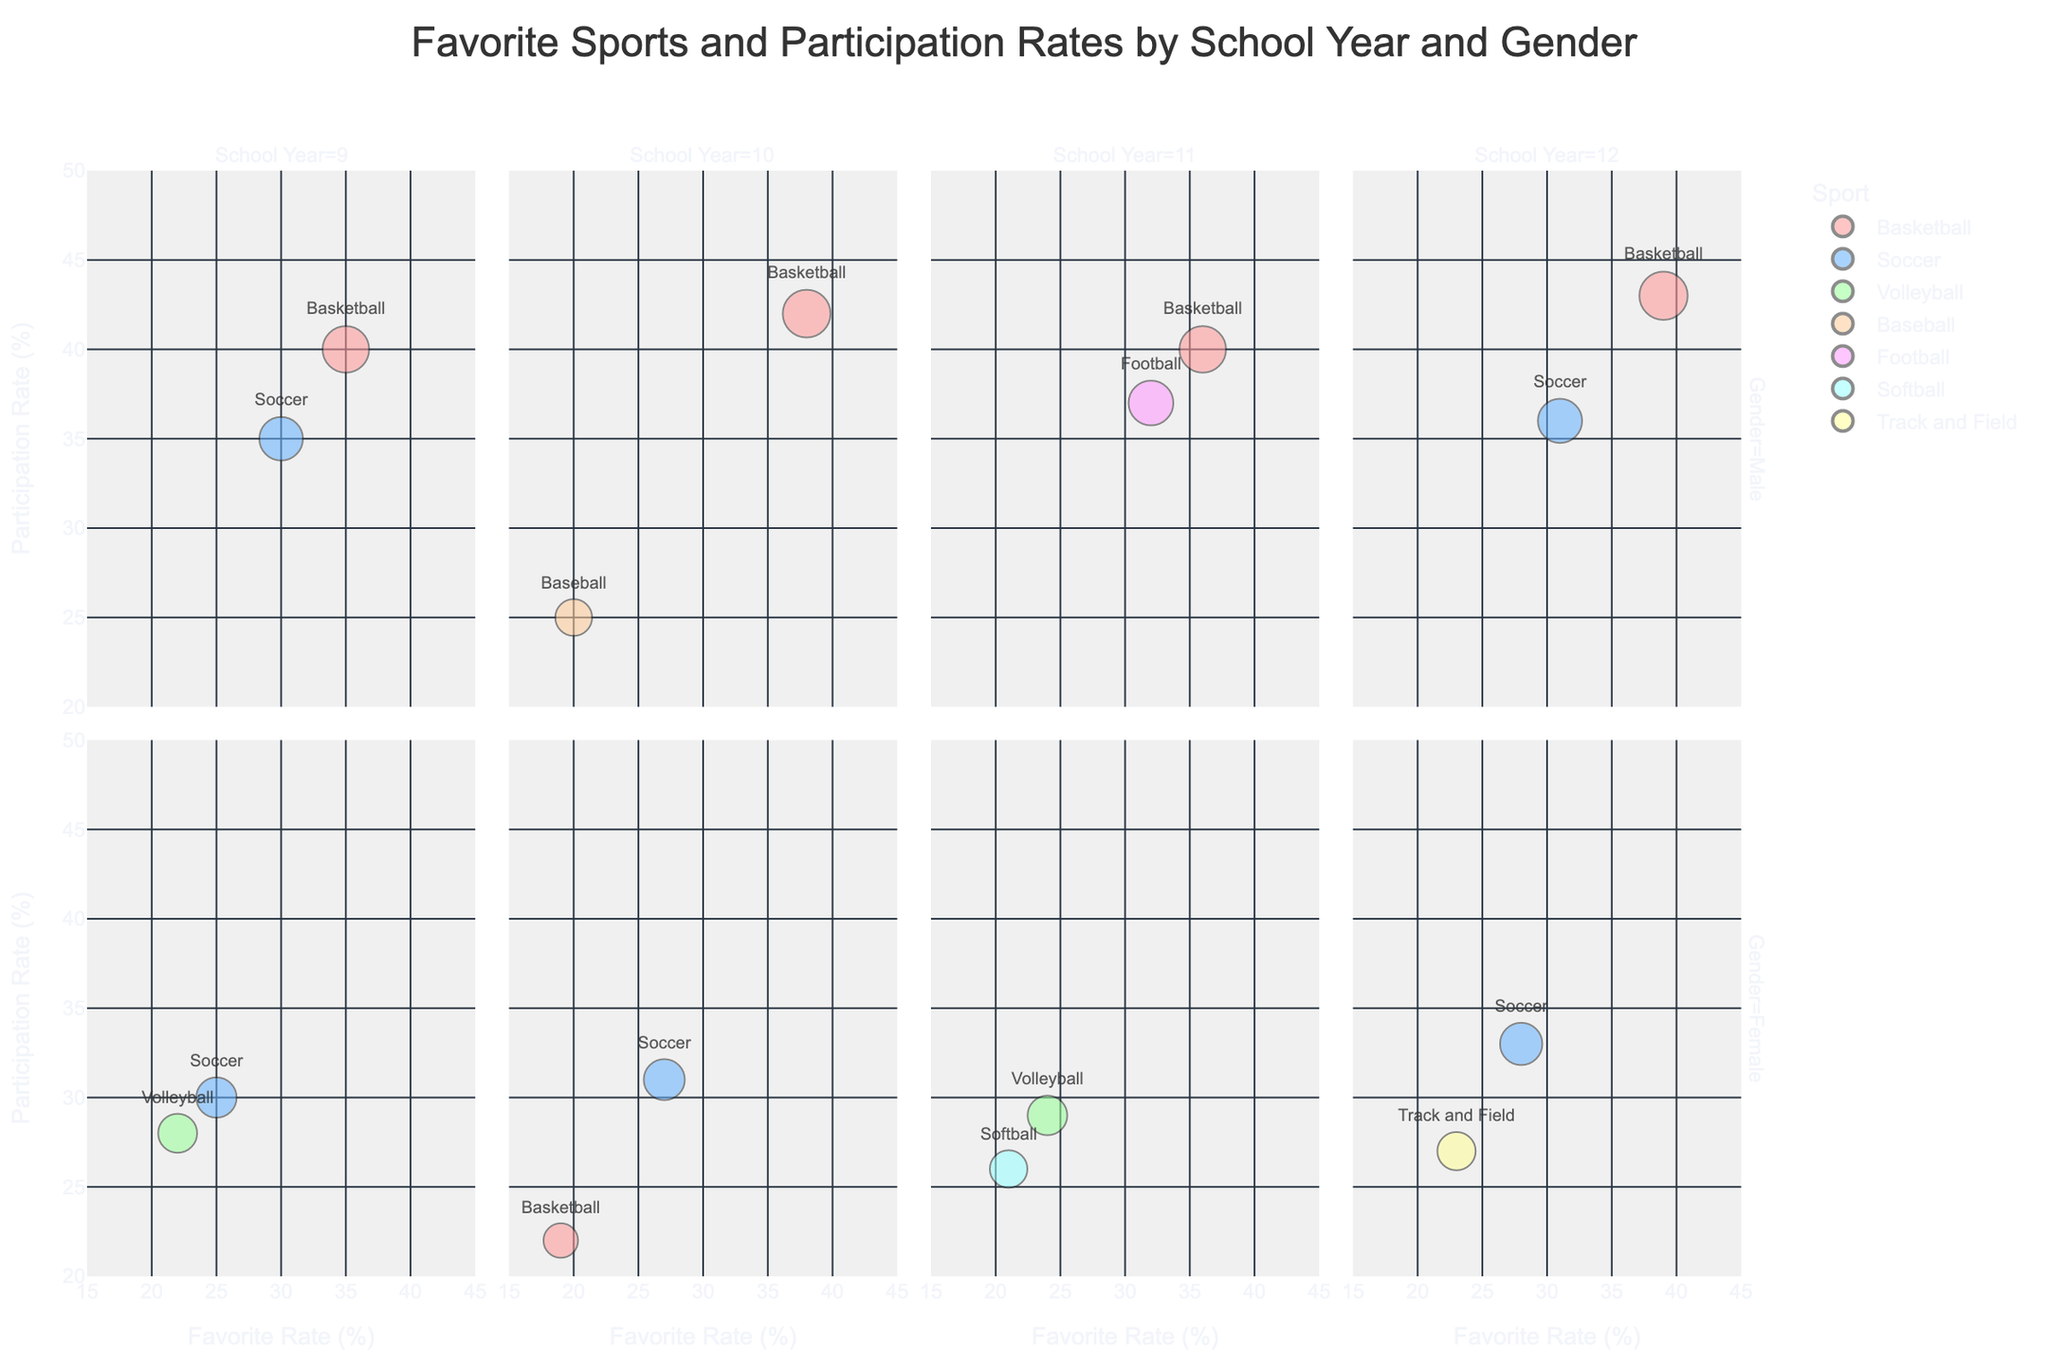Which sport has the highest favorite rate among 9th-grade males? The figure shows a bubble for each sport, categorized by school year and gender. Look at the bubbles in the 9th-grade male pane. Basketball has the highest favorite rate.
Answer: Basketball Which sport has the lowest participation rate among 10th-grade females? Look at the bubbles in the 10th-grade female pane and compare their 'Participation Rate (%)'. Basketball has the lowest participation rate.
Answer: Basketball What is the participation rate for Soccer among 12th-grade females? Identify the bubble for Soccer in the 12th-grade female pane and check the 'Participation Rate (%)'. Soccer has a participation rate of 33%.
Answer: 33% Is the favorite rate of Football higher than that of Baseball for 11th-grade males? Check the 11th-grade male pane and compare the favorite rates for Football and Baseball. Football has a favorite rate of 32%, and Baseball doesn't appear for 11th-grade males.
Answer: Yes Which sport is the most popular (highest favorite rate) among females in each school year? Examine the bubbles representing female students across each school year and identify the highest favorite rates in each pane. Soccer in 9th grade, Soccer in 10th grade, Volleyball in 11th grade, and Soccer in 12th grade are the sports with the highest favorite rates.
Answer: Soccer (9th, 10th, 12th), Volleyball (11th) How many sports are favored by 30% or more of 9th-grade students? Look at the 9th-grade panes (both male and female) and count the sports with a favorite rate of 30% or above. Basketball and Soccer (males) and Soccer (females) are favored by 30% or more.
Answer: 3 What is the overall trend in the favorite rate for Basketball among males from 9th to 12th grade? Observe the bubbles for Basketball in the male panes (9th to 12th grade). The favorite rate for Basketball rises from 35% in 9th grade to 39% in 12th grade.
Answer: Increasing Which gender has the higher participation rate for Soccer in the 9th grade? Compare the participation rates for Soccer between 9th-grade males and females. Males have a participation rate of 35%, and females have a rate of 30%.
Answer: Male How does the favorite rate for Volleyball change from 9th-grade females to 11th-grade females? Check the favorite rates for Volleyball in the 9th-grade and 11th-grade female panes. The favorite rate for Volleyball increases from 22% (9th grade) to 24% (11th grade).
Answer: Increases What is the participation rate for Track and Field among 12th-grade females, and how does it compare to the participation rate for Soccer among the same group? Identify the bubbles for Track and Field and Soccer in the 12th-grade female pane, and compare their participation rates. Track and Field has a participation rate of 27%, while Soccer has a rate of 33%.
Answer: Track and Field: 27%, lower than Soccer 